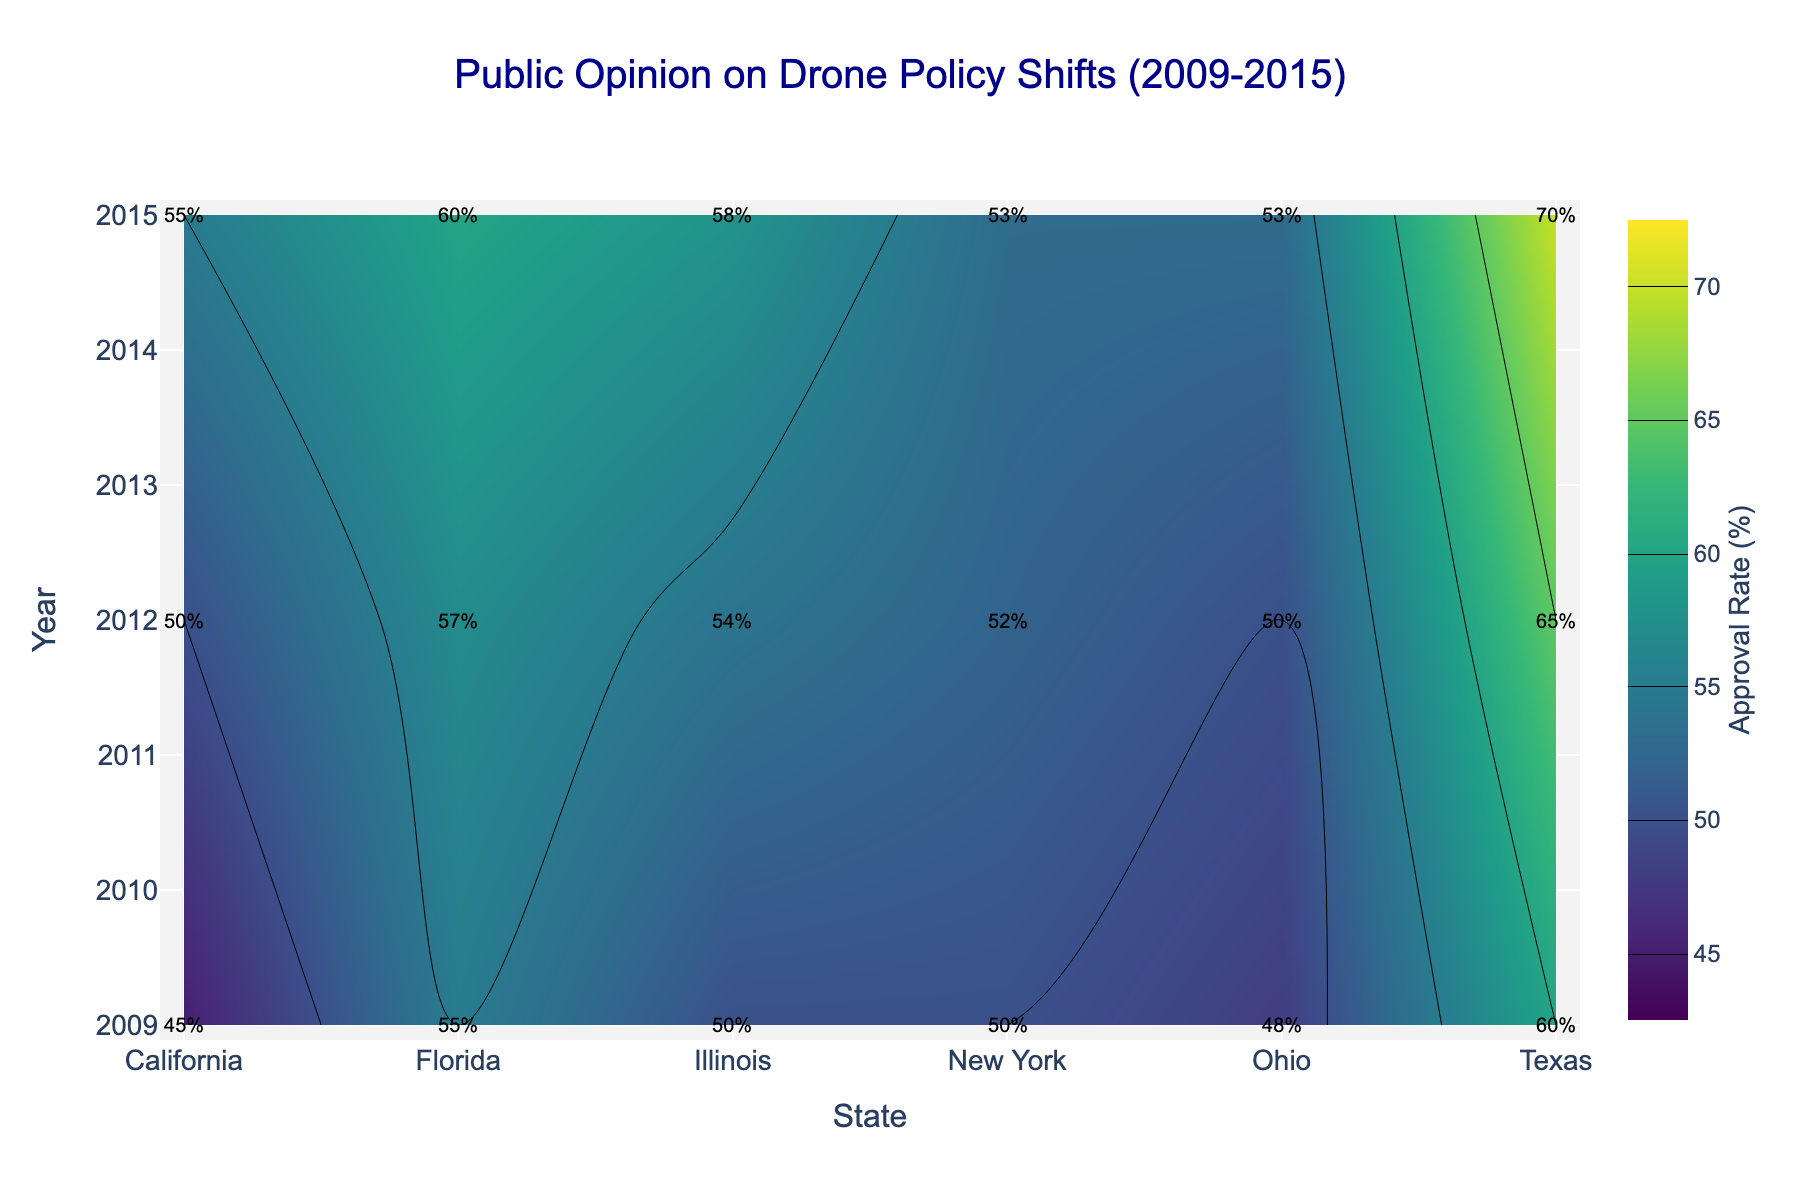How does the approval rate for drone policy in California change from 2009 to 2015? Looking at the plot, find the approval rates for California in 2009, 2012, and 2015. Subtract the 2009 rate from the 2015 rate.
Answer: It increases from 45% to 55%, a 10% increase Which state had the highest approval rate for drone policy in 2015? Check the approval rates for all states in 2015, and identify which state has the highest percentage.
Answer: Texas What is the difference in approval rate between Texas and Ohio in 2009? Find the approval rates for Texas and Ohio in 2009 and subtract Ohio's rate from Texas's rate.
Answer: 12% Which state shows the least change in approval rate from 2009 to 2015? Calculate the difference in approval rates between 2009 and 2015 for each state. The state with the smallest difference shows the least change.
Answer: New York Between 2009 and 2012, which state experienced the largest increase in approval rate? Find the approval rates for all states in 2009 and 2012, then calculate the differences. The state with the largest positive difference experienced the largest increase.
Answer: Illinois Compare the approval rates for California and Florida in 2012. Which state had higher approval? Look at the approval rates for California and Florida in 2012 and compare them. Identify which state has the higher rate.
Answer: Florida How does the trend in approval rates for drone policy in New York compare to that in Texas from 2009 to 2015? Observe the approval rate trend lines for New York and Texas from 2009 to 2015. Determine if they increased, decreased, or remained stable, and compare their trend directions and magnitudes.
Answer: Both increased, but Texas increased more significantly What is the average approval rate for drone policy in Illinois over the years 2009, 2012, and 2015? Sum the approval rates for Illinois in 2009, 2012, and 2015, then divide by the number of years (3).
Answer: (50 + 54 + 58) / 3 = 54% In which year did Ohio see an equilibrium in approval and disapproval rates? Check the years for Ohio where the approval rate equals 50%, indicating equal approval and disapproval rates.
Answer: 2012 Identify a state where the approval rate steadily increased over the three years shown. Observe the trend lines for each state from 2009 to 2015 and find a state with a consistent upward trend.
Answer: Illinois 